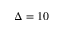<formula> <loc_0><loc_0><loc_500><loc_500>\Delta = 1 0</formula> 